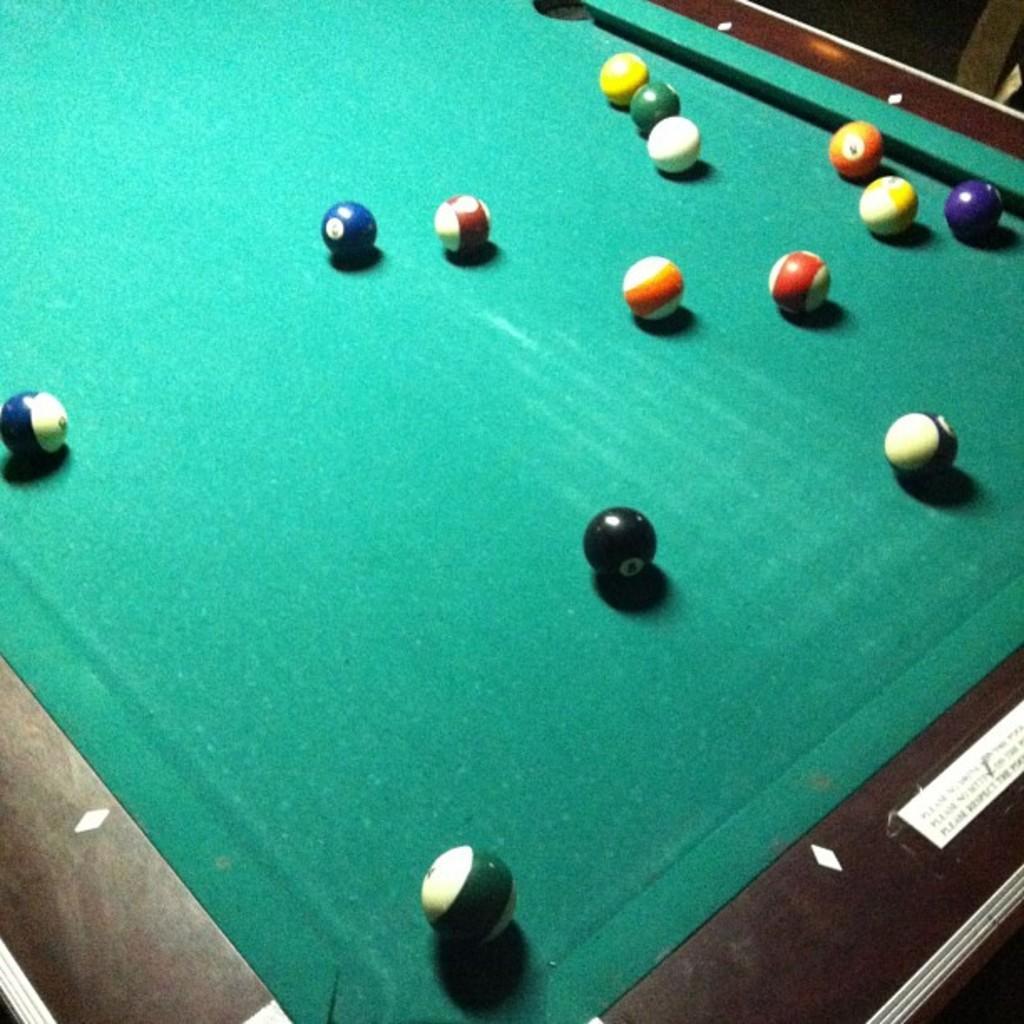Describe this image in one or two sentences. As we can see in the image there is a billiards board and bolls. 